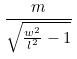<formula> <loc_0><loc_0><loc_500><loc_500>\frac { m } { \sqrt { \frac { w ^ { 2 } } { l ^ { 2 } } - 1 } }</formula> 